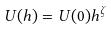<formula> <loc_0><loc_0><loc_500><loc_500>U ( h ) = U ( 0 ) h ^ { \zeta }</formula> 